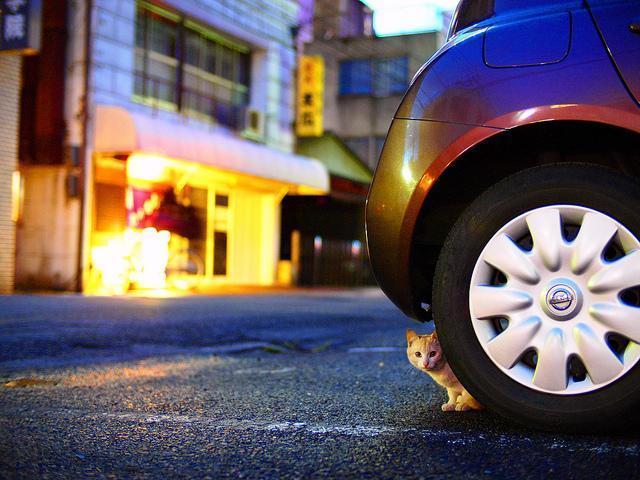How many men are in this picture?
Give a very brief answer. 0. 